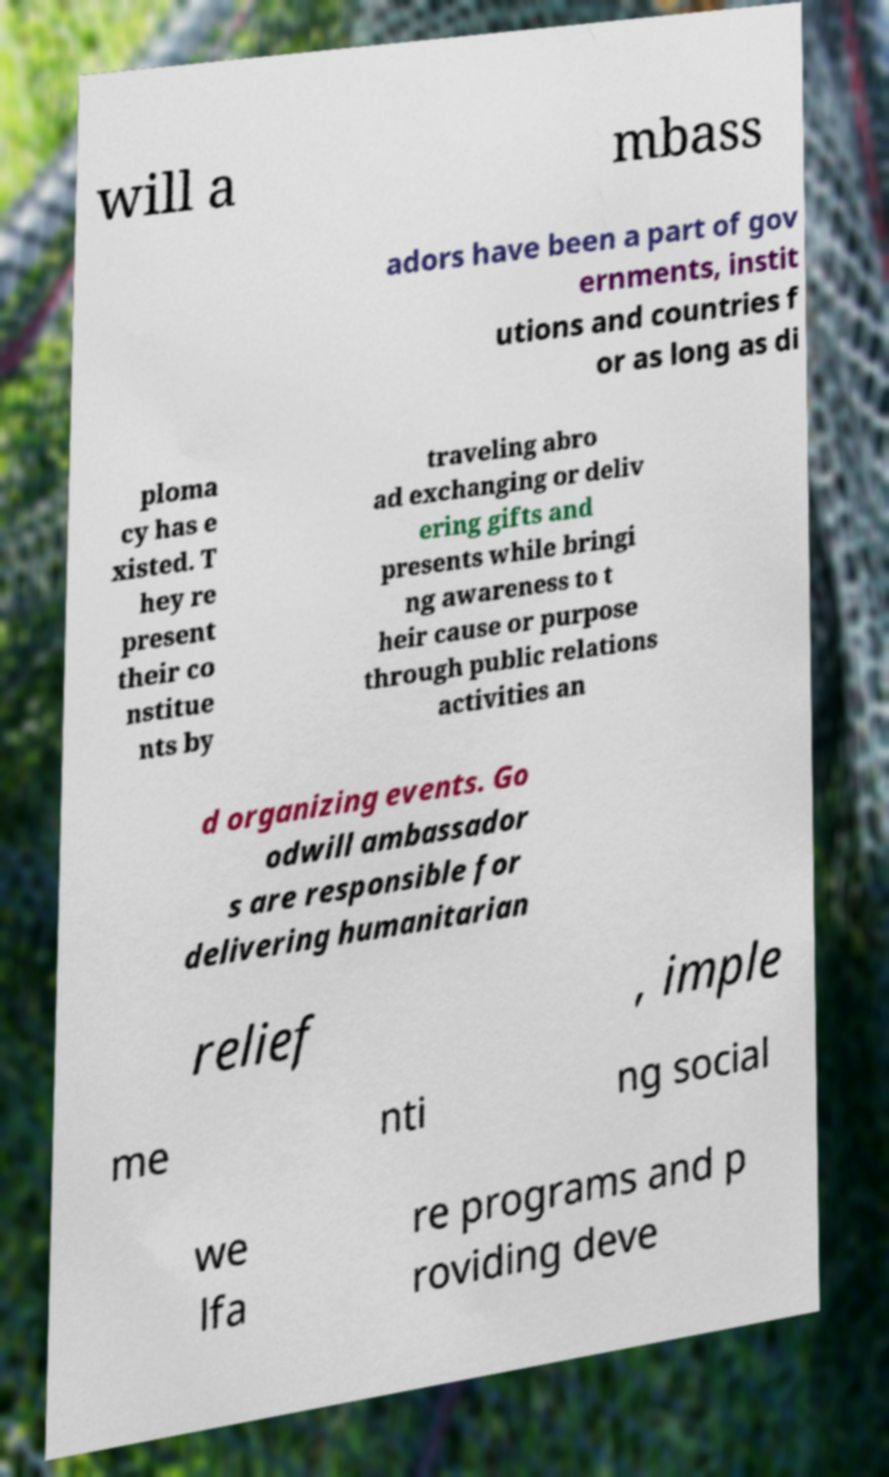There's text embedded in this image that I need extracted. Can you transcribe it verbatim? will a mbass adors have been a part of gov ernments, instit utions and countries f or as long as di ploma cy has e xisted. T hey re present their co nstitue nts by traveling abro ad exchanging or deliv ering gifts and presents while bringi ng awareness to t heir cause or purpose through public relations activities an d organizing events. Go odwill ambassador s are responsible for delivering humanitarian relief , imple me nti ng social we lfa re programs and p roviding deve 